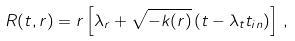<formula> <loc_0><loc_0><loc_500><loc_500>R ( t , r ) = r \left [ \lambda _ { r } + \sqrt { - k ( r ) } \left ( t - \lambda _ { t } t _ { i n } \right ) \right ] \, ,</formula> 